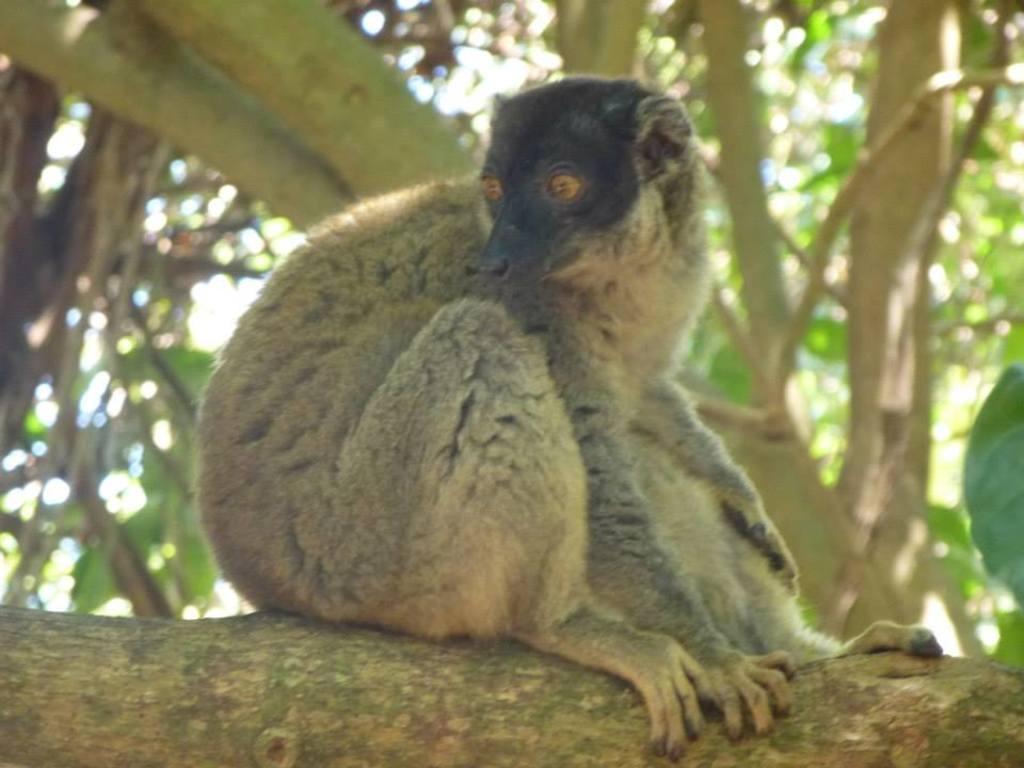Could you give a brief overview of what you see in this image? In this picture I can observe an animal sitting on the branch of a tree. It is looking like a species of monkey. In the background there are trees. 